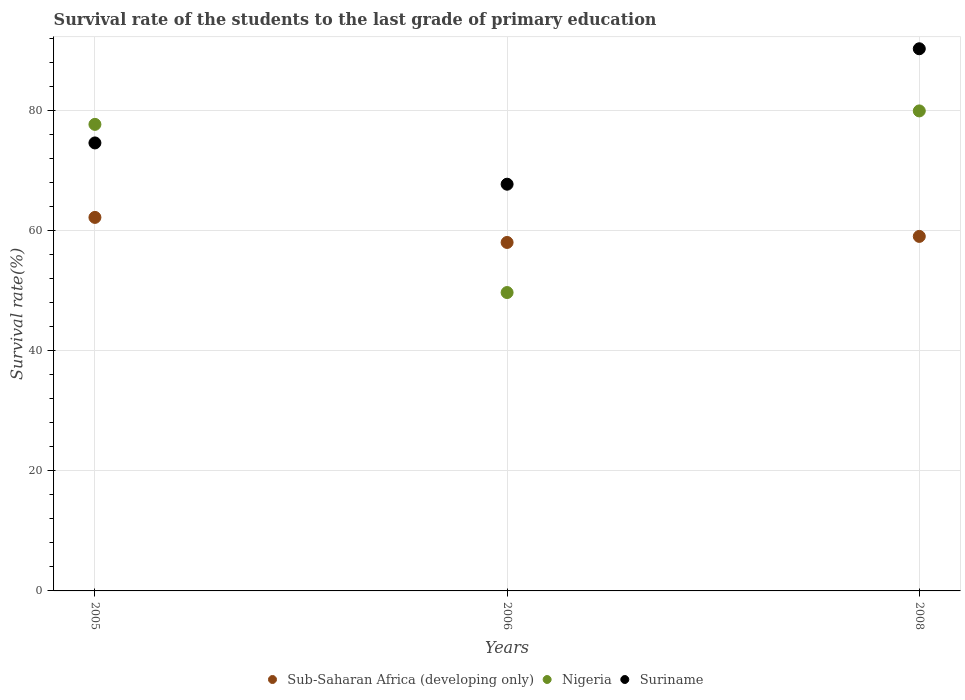How many different coloured dotlines are there?
Provide a short and direct response. 3. What is the survival rate of the students in Nigeria in 2008?
Your answer should be compact. 79.99. Across all years, what is the maximum survival rate of the students in Suriname?
Keep it short and to the point. 90.35. Across all years, what is the minimum survival rate of the students in Sub-Saharan Africa (developing only)?
Provide a short and direct response. 58.07. In which year was the survival rate of the students in Sub-Saharan Africa (developing only) maximum?
Ensure brevity in your answer.  2005. What is the total survival rate of the students in Suriname in the graph?
Offer a terse response. 232.78. What is the difference between the survival rate of the students in Suriname in 2005 and that in 2006?
Offer a very short reply. 6.88. What is the difference between the survival rate of the students in Suriname in 2006 and the survival rate of the students in Nigeria in 2008?
Provide a short and direct response. -12.21. What is the average survival rate of the students in Suriname per year?
Your answer should be very brief. 77.59. In the year 2006, what is the difference between the survival rate of the students in Nigeria and survival rate of the students in Suriname?
Ensure brevity in your answer.  -18.05. In how many years, is the survival rate of the students in Sub-Saharan Africa (developing only) greater than 80 %?
Offer a terse response. 0. What is the ratio of the survival rate of the students in Nigeria in 2006 to that in 2008?
Ensure brevity in your answer.  0.62. Is the survival rate of the students in Sub-Saharan Africa (developing only) in 2005 less than that in 2008?
Provide a succinct answer. No. Is the difference between the survival rate of the students in Nigeria in 2006 and 2008 greater than the difference between the survival rate of the students in Suriname in 2006 and 2008?
Offer a terse response. No. What is the difference between the highest and the second highest survival rate of the students in Suriname?
Your response must be concise. 15.69. What is the difference between the highest and the lowest survival rate of the students in Sub-Saharan Africa (developing only)?
Make the answer very short. 4.17. Is it the case that in every year, the sum of the survival rate of the students in Sub-Saharan Africa (developing only) and survival rate of the students in Nigeria  is greater than the survival rate of the students in Suriname?
Offer a very short reply. Yes. Does the survival rate of the students in Sub-Saharan Africa (developing only) monotonically increase over the years?
Your response must be concise. No. Is the survival rate of the students in Sub-Saharan Africa (developing only) strictly greater than the survival rate of the students in Suriname over the years?
Ensure brevity in your answer.  No. Is the survival rate of the students in Suriname strictly less than the survival rate of the students in Nigeria over the years?
Keep it short and to the point. No. How many dotlines are there?
Offer a very short reply. 3. Are the values on the major ticks of Y-axis written in scientific E-notation?
Provide a short and direct response. No. Does the graph contain any zero values?
Your answer should be compact. No. Does the graph contain grids?
Provide a short and direct response. Yes. How are the legend labels stacked?
Give a very brief answer. Horizontal. What is the title of the graph?
Offer a terse response. Survival rate of the students to the last grade of primary education. What is the label or title of the X-axis?
Keep it short and to the point. Years. What is the label or title of the Y-axis?
Your answer should be compact. Survival rate(%). What is the Survival rate(%) of Sub-Saharan Africa (developing only) in 2005?
Provide a succinct answer. 62.24. What is the Survival rate(%) of Nigeria in 2005?
Offer a terse response. 77.75. What is the Survival rate(%) of Suriname in 2005?
Provide a succinct answer. 74.66. What is the Survival rate(%) in Sub-Saharan Africa (developing only) in 2006?
Your answer should be very brief. 58.07. What is the Survival rate(%) in Nigeria in 2006?
Your response must be concise. 49.72. What is the Survival rate(%) of Suriname in 2006?
Provide a succinct answer. 67.78. What is the Survival rate(%) of Sub-Saharan Africa (developing only) in 2008?
Your answer should be compact. 59.08. What is the Survival rate(%) in Nigeria in 2008?
Give a very brief answer. 79.99. What is the Survival rate(%) of Suriname in 2008?
Your answer should be compact. 90.35. Across all years, what is the maximum Survival rate(%) in Sub-Saharan Africa (developing only)?
Provide a short and direct response. 62.24. Across all years, what is the maximum Survival rate(%) in Nigeria?
Your response must be concise. 79.99. Across all years, what is the maximum Survival rate(%) in Suriname?
Make the answer very short. 90.35. Across all years, what is the minimum Survival rate(%) in Sub-Saharan Africa (developing only)?
Provide a succinct answer. 58.07. Across all years, what is the minimum Survival rate(%) of Nigeria?
Your answer should be very brief. 49.72. Across all years, what is the minimum Survival rate(%) of Suriname?
Ensure brevity in your answer.  67.78. What is the total Survival rate(%) in Sub-Saharan Africa (developing only) in the graph?
Your answer should be very brief. 179.39. What is the total Survival rate(%) in Nigeria in the graph?
Give a very brief answer. 207.46. What is the total Survival rate(%) of Suriname in the graph?
Offer a terse response. 232.78. What is the difference between the Survival rate(%) in Sub-Saharan Africa (developing only) in 2005 and that in 2006?
Your response must be concise. 4.17. What is the difference between the Survival rate(%) of Nigeria in 2005 and that in 2006?
Provide a succinct answer. 28.02. What is the difference between the Survival rate(%) of Suriname in 2005 and that in 2006?
Offer a terse response. 6.88. What is the difference between the Survival rate(%) in Sub-Saharan Africa (developing only) in 2005 and that in 2008?
Your response must be concise. 3.17. What is the difference between the Survival rate(%) of Nigeria in 2005 and that in 2008?
Your answer should be compact. -2.24. What is the difference between the Survival rate(%) of Suriname in 2005 and that in 2008?
Your answer should be very brief. -15.69. What is the difference between the Survival rate(%) of Sub-Saharan Africa (developing only) in 2006 and that in 2008?
Ensure brevity in your answer.  -1.01. What is the difference between the Survival rate(%) in Nigeria in 2006 and that in 2008?
Ensure brevity in your answer.  -30.27. What is the difference between the Survival rate(%) in Suriname in 2006 and that in 2008?
Your answer should be compact. -22.57. What is the difference between the Survival rate(%) in Sub-Saharan Africa (developing only) in 2005 and the Survival rate(%) in Nigeria in 2006?
Provide a short and direct response. 12.52. What is the difference between the Survival rate(%) in Sub-Saharan Africa (developing only) in 2005 and the Survival rate(%) in Suriname in 2006?
Provide a short and direct response. -5.53. What is the difference between the Survival rate(%) in Nigeria in 2005 and the Survival rate(%) in Suriname in 2006?
Give a very brief answer. 9.97. What is the difference between the Survival rate(%) of Sub-Saharan Africa (developing only) in 2005 and the Survival rate(%) of Nigeria in 2008?
Provide a short and direct response. -17.75. What is the difference between the Survival rate(%) in Sub-Saharan Africa (developing only) in 2005 and the Survival rate(%) in Suriname in 2008?
Offer a very short reply. -28.1. What is the difference between the Survival rate(%) of Nigeria in 2005 and the Survival rate(%) of Suriname in 2008?
Make the answer very short. -12.6. What is the difference between the Survival rate(%) of Sub-Saharan Africa (developing only) in 2006 and the Survival rate(%) of Nigeria in 2008?
Make the answer very short. -21.92. What is the difference between the Survival rate(%) of Sub-Saharan Africa (developing only) in 2006 and the Survival rate(%) of Suriname in 2008?
Keep it short and to the point. -32.28. What is the difference between the Survival rate(%) in Nigeria in 2006 and the Survival rate(%) in Suriname in 2008?
Offer a terse response. -40.62. What is the average Survival rate(%) in Sub-Saharan Africa (developing only) per year?
Offer a very short reply. 59.8. What is the average Survival rate(%) of Nigeria per year?
Keep it short and to the point. 69.15. What is the average Survival rate(%) in Suriname per year?
Make the answer very short. 77.59. In the year 2005, what is the difference between the Survival rate(%) of Sub-Saharan Africa (developing only) and Survival rate(%) of Nigeria?
Your answer should be compact. -15.5. In the year 2005, what is the difference between the Survival rate(%) of Sub-Saharan Africa (developing only) and Survival rate(%) of Suriname?
Your response must be concise. -12.41. In the year 2005, what is the difference between the Survival rate(%) of Nigeria and Survival rate(%) of Suriname?
Your answer should be very brief. 3.09. In the year 2006, what is the difference between the Survival rate(%) in Sub-Saharan Africa (developing only) and Survival rate(%) in Nigeria?
Ensure brevity in your answer.  8.35. In the year 2006, what is the difference between the Survival rate(%) in Sub-Saharan Africa (developing only) and Survival rate(%) in Suriname?
Your answer should be very brief. -9.71. In the year 2006, what is the difference between the Survival rate(%) of Nigeria and Survival rate(%) of Suriname?
Provide a short and direct response. -18.05. In the year 2008, what is the difference between the Survival rate(%) in Sub-Saharan Africa (developing only) and Survival rate(%) in Nigeria?
Provide a short and direct response. -20.91. In the year 2008, what is the difference between the Survival rate(%) of Sub-Saharan Africa (developing only) and Survival rate(%) of Suriname?
Offer a very short reply. -31.27. In the year 2008, what is the difference between the Survival rate(%) of Nigeria and Survival rate(%) of Suriname?
Your answer should be compact. -10.36. What is the ratio of the Survival rate(%) in Sub-Saharan Africa (developing only) in 2005 to that in 2006?
Ensure brevity in your answer.  1.07. What is the ratio of the Survival rate(%) in Nigeria in 2005 to that in 2006?
Offer a terse response. 1.56. What is the ratio of the Survival rate(%) of Suriname in 2005 to that in 2006?
Your response must be concise. 1.1. What is the ratio of the Survival rate(%) of Sub-Saharan Africa (developing only) in 2005 to that in 2008?
Your answer should be compact. 1.05. What is the ratio of the Survival rate(%) in Suriname in 2005 to that in 2008?
Your answer should be very brief. 0.83. What is the ratio of the Survival rate(%) in Sub-Saharan Africa (developing only) in 2006 to that in 2008?
Your response must be concise. 0.98. What is the ratio of the Survival rate(%) of Nigeria in 2006 to that in 2008?
Keep it short and to the point. 0.62. What is the ratio of the Survival rate(%) in Suriname in 2006 to that in 2008?
Provide a succinct answer. 0.75. What is the difference between the highest and the second highest Survival rate(%) of Sub-Saharan Africa (developing only)?
Provide a succinct answer. 3.17. What is the difference between the highest and the second highest Survival rate(%) in Nigeria?
Provide a short and direct response. 2.24. What is the difference between the highest and the second highest Survival rate(%) in Suriname?
Your answer should be compact. 15.69. What is the difference between the highest and the lowest Survival rate(%) in Sub-Saharan Africa (developing only)?
Keep it short and to the point. 4.17. What is the difference between the highest and the lowest Survival rate(%) of Nigeria?
Offer a terse response. 30.27. What is the difference between the highest and the lowest Survival rate(%) in Suriname?
Keep it short and to the point. 22.57. 